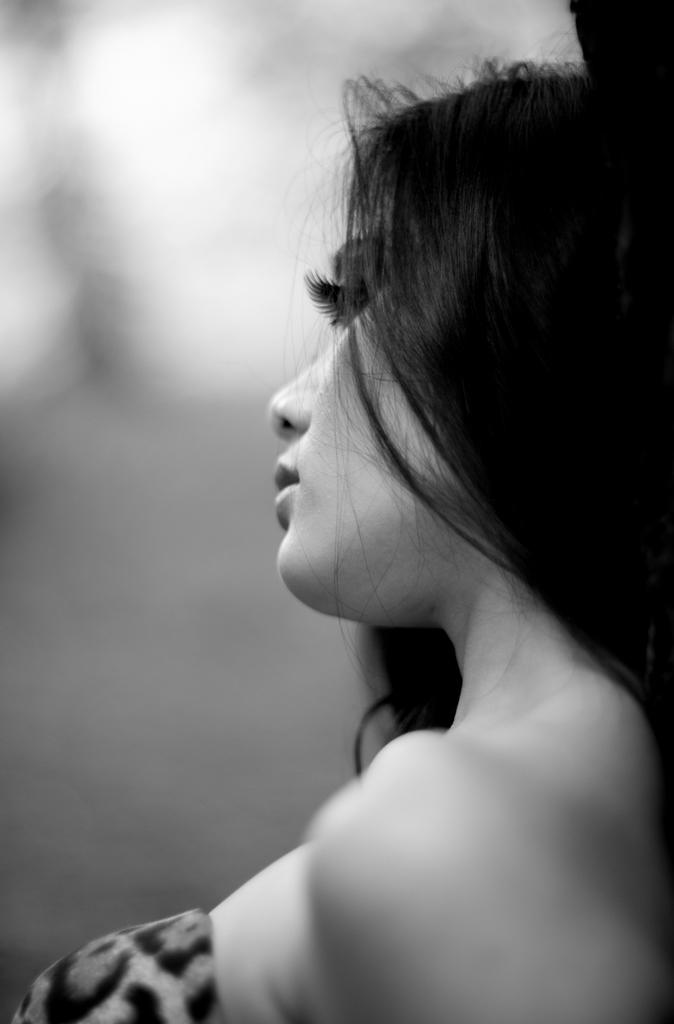What is the color scheme of the picture? The picture is black and white. Who is present in the image? There is a woman in the picture. Can you describe the background of the image? The background of the picture is blurry. What type of notebook is the woman using to solve arithmetic problems in the image? There is no notebook or arithmetic problems present in the image; it features a woman in a black and white setting with a blurry background. 